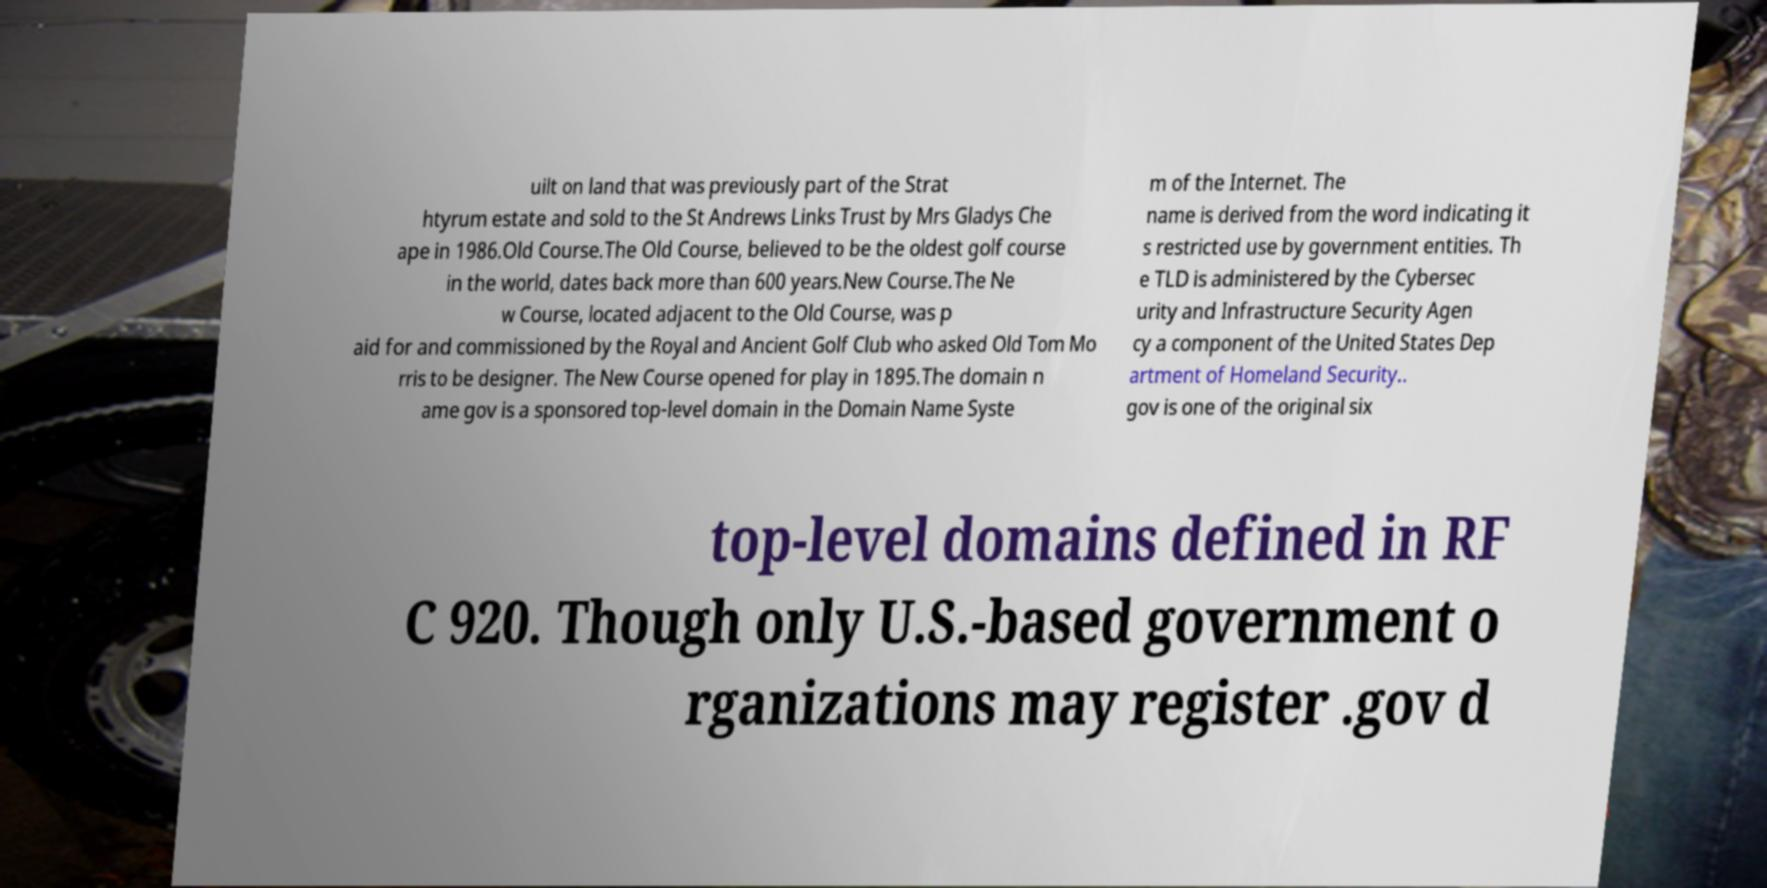There's text embedded in this image that I need extracted. Can you transcribe it verbatim? uilt on land that was previously part of the Strat htyrum estate and sold to the St Andrews Links Trust by Mrs Gladys Che ape in 1986.Old Course.The Old Course, believed to be the oldest golf course in the world, dates back more than 600 years.New Course.The Ne w Course, located adjacent to the Old Course, was p aid for and commissioned by the Royal and Ancient Golf Club who asked Old Tom Mo rris to be designer. The New Course opened for play in 1895.The domain n ame gov is a sponsored top-level domain in the Domain Name Syste m of the Internet. The name is derived from the word indicating it s restricted use by government entities. Th e TLD is administered by the Cybersec urity and Infrastructure Security Agen cy a component of the United States Dep artment of Homeland Security.. gov is one of the original six top-level domains defined in RF C 920. Though only U.S.-based government o rganizations may register .gov d 